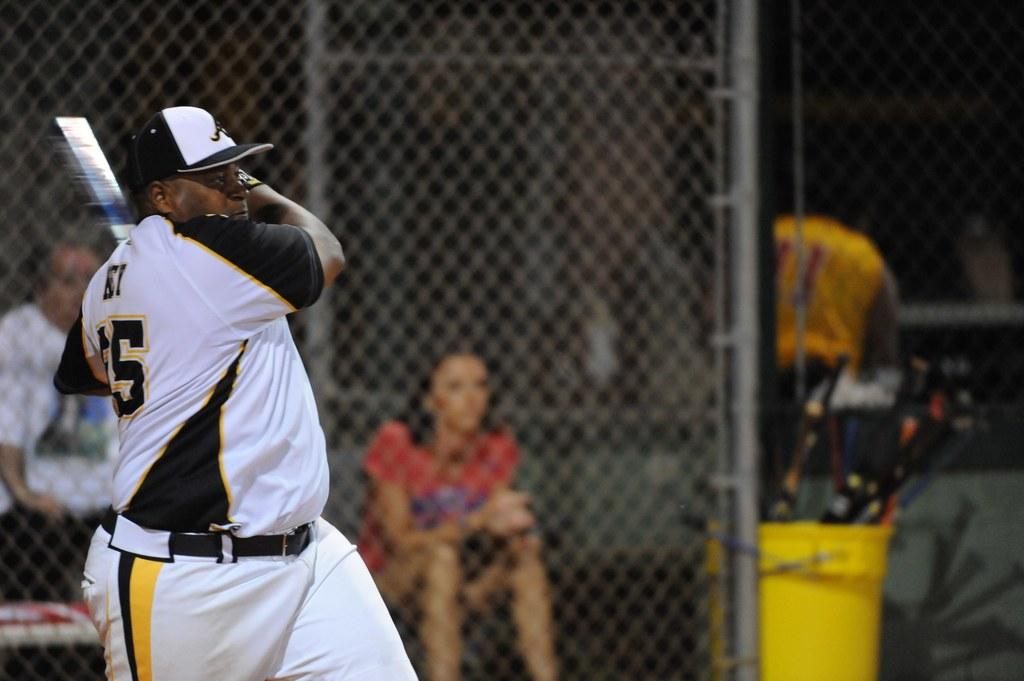Provide a one-sentence caption for the provided image. A woman sits in a dugout while a man with the number 5 on his jersey hits a ball. 